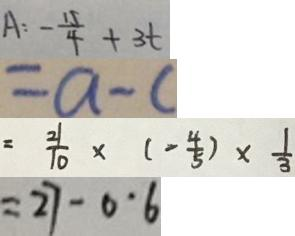<formula> <loc_0><loc_0><loc_500><loc_500>A : - \frac { 1 5 } { 4 } + 3 t 
 = a - c 
 = \frac { 2 1 } { 1 0 } \times ( - \frac { 4 } { 5 } ) \times \frac { 1 } { 3 } 
 = 2 7 - 0 \cdot 6</formula> 